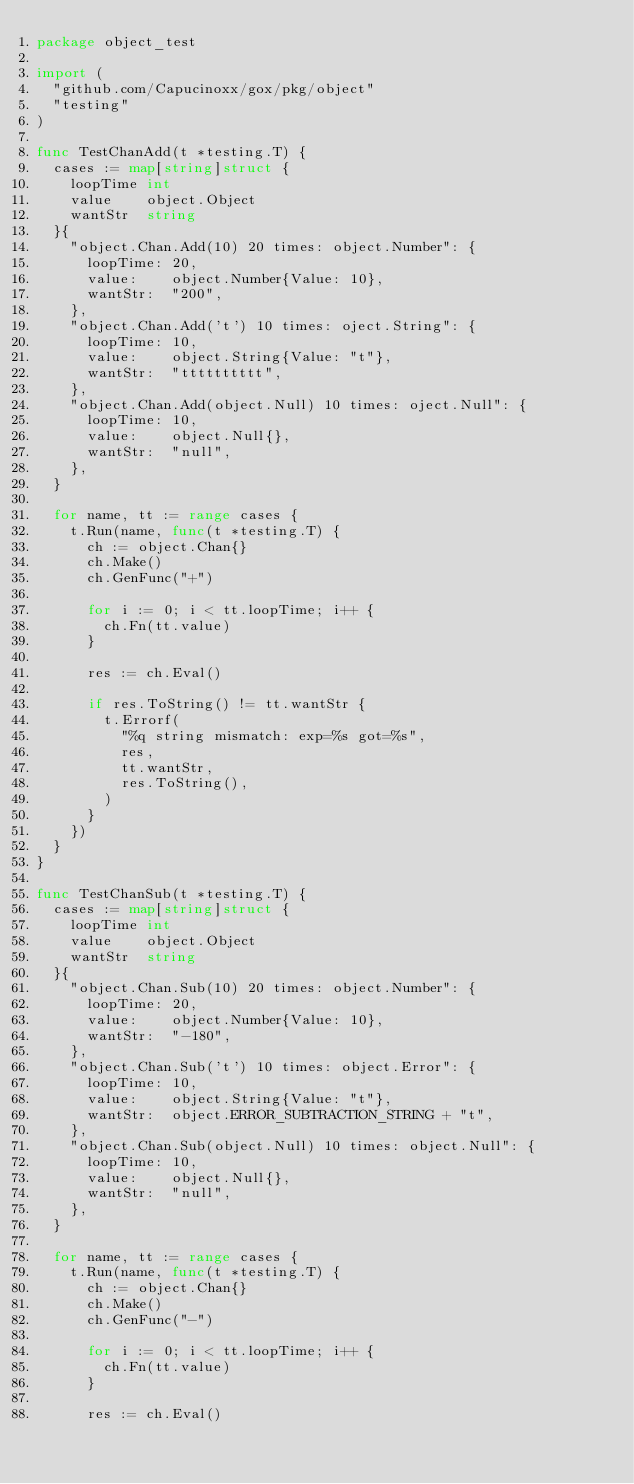<code> <loc_0><loc_0><loc_500><loc_500><_Go_>package object_test

import (
	"github.com/Capucinoxx/gox/pkg/object"
	"testing"
)

func TestChanAdd(t *testing.T) {
	cases := map[string]struct {
		loopTime int
		value    object.Object
		wantStr  string
	}{
		"object.Chan.Add(10) 20 times: object.Number": {
			loopTime: 20,
			value:    object.Number{Value: 10},
			wantStr:  "200",
		},
		"object.Chan.Add('t') 10 times: oject.String": {
			loopTime: 10,
			value:    object.String{Value: "t"},
			wantStr:  "tttttttttt",
		},
		"object.Chan.Add(object.Null) 10 times: oject.Null": {
			loopTime: 10,
			value:    object.Null{},
			wantStr:  "null",
		},
	}

	for name, tt := range cases {
		t.Run(name, func(t *testing.T) {
			ch := object.Chan{}
			ch.Make()
			ch.GenFunc("+")

			for i := 0; i < tt.loopTime; i++ {
				ch.Fn(tt.value)
			}

			res := ch.Eval()

			if res.ToString() != tt.wantStr {
				t.Errorf(
					"%q string mismatch: exp=%s got=%s",
					res,
					tt.wantStr,
					res.ToString(),
				)
			}
		})
	}
}

func TestChanSub(t *testing.T) {
	cases := map[string]struct {
		loopTime int
		value    object.Object
		wantStr  string
	}{
		"object.Chan.Sub(10) 20 times: object.Number": {
			loopTime: 20,
			value:    object.Number{Value: 10},
			wantStr:  "-180",
		},
		"object.Chan.Sub('t') 10 times: object.Error": {
			loopTime: 10,
			value:    object.String{Value: "t"},
			wantStr:  object.ERROR_SUBTRACTION_STRING + "t",
		},
		"object.Chan.Sub(object.Null) 10 times: object.Null": {
			loopTime: 10,
			value:    object.Null{},
			wantStr:  "null",
		},
	}

	for name, tt := range cases {
		t.Run(name, func(t *testing.T) {
			ch := object.Chan{}
			ch.Make()
			ch.GenFunc("-")

			for i := 0; i < tt.loopTime; i++ {
				ch.Fn(tt.value)
			}

			res := ch.Eval()
</code> 